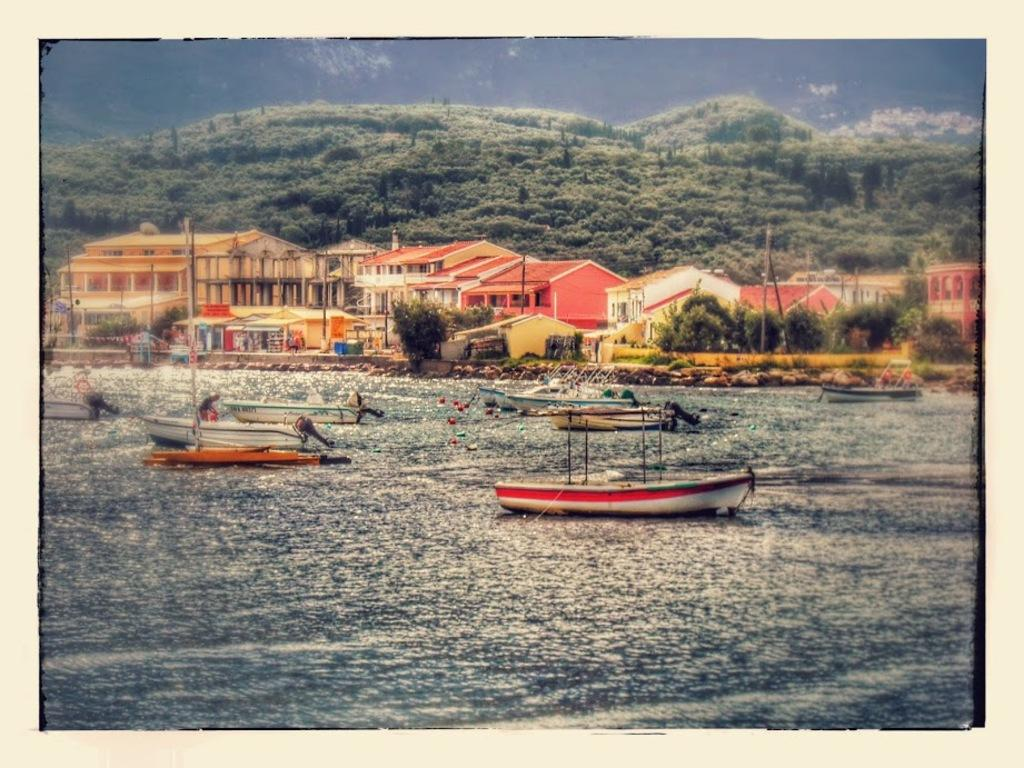What is the main subject of the image? There is a picture in the image. What can be seen in the picture? The picture contains water and boats. What else is visible in the image besides the picture? There are buildings, trees, and the sky visible in the image. What language is spoken by the sister in the image? There is no sister present in the image, and therefore no language can be attributed to her. 